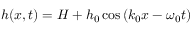<formula> <loc_0><loc_0><loc_500><loc_500>h ( x , t ) = H + h _ { 0 } \cos \left ( k _ { 0 } x - \omega _ { 0 } t \right )</formula> 